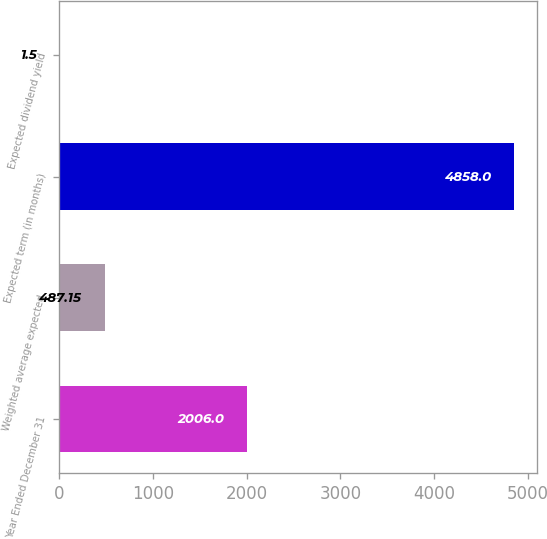Convert chart to OTSL. <chart><loc_0><loc_0><loc_500><loc_500><bar_chart><fcel>Year Ended December 31<fcel>Weighted average expected<fcel>Expected term (in months)<fcel>Expected dividend yield<nl><fcel>2006<fcel>487.15<fcel>4858<fcel>1.5<nl></chart> 